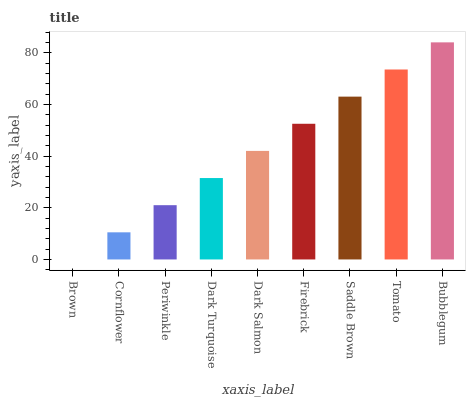Is Brown the minimum?
Answer yes or no. Yes. Is Bubblegum the maximum?
Answer yes or no. Yes. Is Cornflower the minimum?
Answer yes or no. No. Is Cornflower the maximum?
Answer yes or no. No. Is Cornflower greater than Brown?
Answer yes or no. Yes. Is Brown less than Cornflower?
Answer yes or no. Yes. Is Brown greater than Cornflower?
Answer yes or no. No. Is Cornflower less than Brown?
Answer yes or no. No. Is Dark Salmon the high median?
Answer yes or no. Yes. Is Dark Salmon the low median?
Answer yes or no. Yes. Is Bubblegum the high median?
Answer yes or no. No. Is Cornflower the low median?
Answer yes or no. No. 